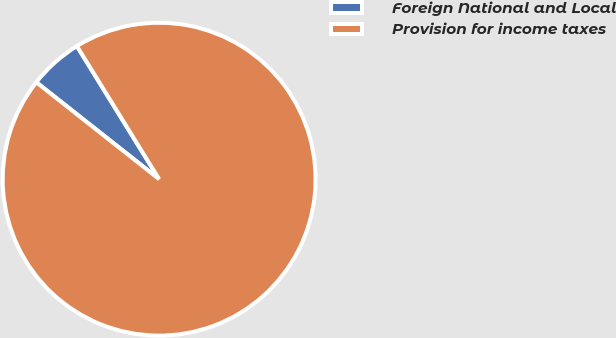Convert chart. <chart><loc_0><loc_0><loc_500><loc_500><pie_chart><fcel>Foreign National and Local<fcel>Provision for income taxes<nl><fcel>5.56%<fcel>94.44%<nl></chart> 